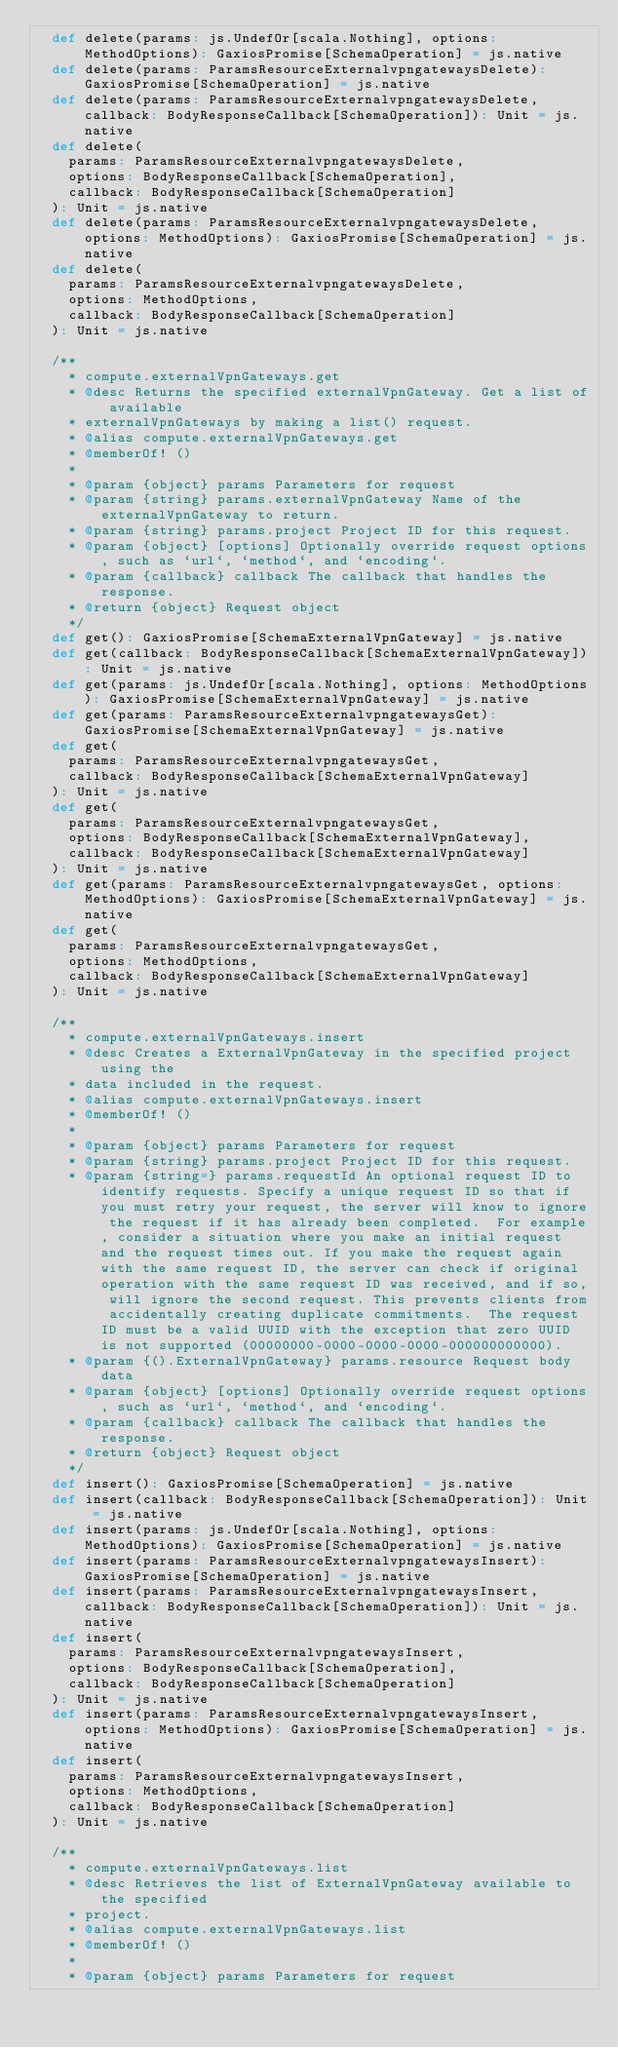<code> <loc_0><loc_0><loc_500><loc_500><_Scala_>  def delete(params: js.UndefOr[scala.Nothing], options: MethodOptions): GaxiosPromise[SchemaOperation] = js.native
  def delete(params: ParamsResourceExternalvpngatewaysDelete): GaxiosPromise[SchemaOperation] = js.native
  def delete(params: ParamsResourceExternalvpngatewaysDelete, callback: BodyResponseCallback[SchemaOperation]): Unit = js.native
  def delete(
    params: ParamsResourceExternalvpngatewaysDelete,
    options: BodyResponseCallback[SchemaOperation],
    callback: BodyResponseCallback[SchemaOperation]
  ): Unit = js.native
  def delete(params: ParamsResourceExternalvpngatewaysDelete, options: MethodOptions): GaxiosPromise[SchemaOperation] = js.native
  def delete(
    params: ParamsResourceExternalvpngatewaysDelete,
    options: MethodOptions,
    callback: BodyResponseCallback[SchemaOperation]
  ): Unit = js.native
  
  /**
    * compute.externalVpnGateways.get
    * @desc Returns the specified externalVpnGateway. Get a list of available
    * externalVpnGateways by making a list() request.
    * @alias compute.externalVpnGateways.get
    * @memberOf! ()
    *
    * @param {object} params Parameters for request
    * @param {string} params.externalVpnGateway Name of the externalVpnGateway to return.
    * @param {string} params.project Project ID for this request.
    * @param {object} [options] Optionally override request options, such as `url`, `method`, and `encoding`.
    * @param {callback} callback The callback that handles the response.
    * @return {object} Request object
    */
  def get(): GaxiosPromise[SchemaExternalVpnGateway] = js.native
  def get(callback: BodyResponseCallback[SchemaExternalVpnGateway]): Unit = js.native
  def get(params: js.UndefOr[scala.Nothing], options: MethodOptions): GaxiosPromise[SchemaExternalVpnGateway] = js.native
  def get(params: ParamsResourceExternalvpngatewaysGet): GaxiosPromise[SchemaExternalVpnGateway] = js.native
  def get(
    params: ParamsResourceExternalvpngatewaysGet,
    callback: BodyResponseCallback[SchemaExternalVpnGateway]
  ): Unit = js.native
  def get(
    params: ParamsResourceExternalvpngatewaysGet,
    options: BodyResponseCallback[SchemaExternalVpnGateway],
    callback: BodyResponseCallback[SchemaExternalVpnGateway]
  ): Unit = js.native
  def get(params: ParamsResourceExternalvpngatewaysGet, options: MethodOptions): GaxiosPromise[SchemaExternalVpnGateway] = js.native
  def get(
    params: ParamsResourceExternalvpngatewaysGet,
    options: MethodOptions,
    callback: BodyResponseCallback[SchemaExternalVpnGateway]
  ): Unit = js.native
  
  /**
    * compute.externalVpnGateways.insert
    * @desc Creates a ExternalVpnGateway in the specified project using the
    * data included in the request.
    * @alias compute.externalVpnGateways.insert
    * @memberOf! ()
    *
    * @param {object} params Parameters for request
    * @param {string} params.project Project ID for this request.
    * @param {string=} params.requestId An optional request ID to identify requests. Specify a unique request ID so that if you must retry your request, the server will know to ignore the request if it has already been completed.  For example, consider a situation where you make an initial request and the request times out. If you make the request again with the same request ID, the server can check if original operation with the same request ID was received, and if so, will ignore the second request. This prevents clients from accidentally creating duplicate commitments.  The request ID must be a valid UUID with the exception that zero UUID is not supported (00000000-0000-0000-0000-000000000000).
    * @param {().ExternalVpnGateway} params.resource Request body data
    * @param {object} [options] Optionally override request options, such as `url`, `method`, and `encoding`.
    * @param {callback} callback The callback that handles the response.
    * @return {object} Request object
    */
  def insert(): GaxiosPromise[SchemaOperation] = js.native
  def insert(callback: BodyResponseCallback[SchemaOperation]): Unit = js.native
  def insert(params: js.UndefOr[scala.Nothing], options: MethodOptions): GaxiosPromise[SchemaOperation] = js.native
  def insert(params: ParamsResourceExternalvpngatewaysInsert): GaxiosPromise[SchemaOperation] = js.native
  def insert(params: ParamsResourceExternalvpngatewaysInsert, callback: BodyResponseCallback[SchemaOperation]): Unit = js.native
  def insert(
    params: ParamsResourceExternalvpngatewaysInsert,
    options: BodyResponseCallback[SchemaOperation],
    callback: BodyResponseCallback[SchemaOperation]
  ): Unit = js.native
  def insert(params: ParamsResourceExternalvpngatewaysInsert, options: MethodOptions): GaxiosPromise[SchemaOperation] = js.native
  def insert(
    params: ParamsResourceExternalvpngatewaysInsert,
    options: MethodOptions,
    callback: BodyResponseCallback[SchemaOperation]
  ): Unit = js.native
  
  /**
    * compute.externalVpnGateways.list
    * @desc Retrieves the list of ExternalVpnGateway available to the specified
    * project.
    * @alias compute.externalVpnGateways.list
    * @memberOf! ()
    *
    * @param {object} params Parameters for request</code> 